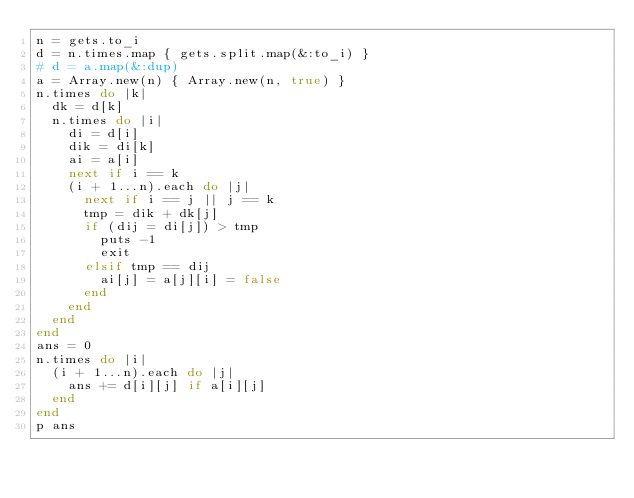<code> <loc_0><loc_0><loc_500><loc_500><_Ruby_>n = gets.to_i
d = n.times.map { gets.split.map(&:to_i) }
# d = a.map(&:dup)
a = Array.new(n) { Array.new(n, true) }
n.times do |k|
  dk = d[k]
  n.times do |i|
    di = d[i]
    dik = di[k]
    ai = a[i]
    next if i == k
    (i + 1...n).each do |j|
      next if i == j || j == k
      tmp = dik + dk[j]
      if (dij = di[j]) > tmp
        puts -1
        exit
      elsif tmp == dij
        ai[j] = a[j][i] = false
      end
    end
  end
end
ans = 0
n.times do |i|
  (i + 1...n).each do |j|
    ans += d[i][j] if a[i][j]
  end
end
p ans
</code> 